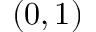Convert formula to latex. <formula><loc_0><loc_0><loc_500><loc_500>( 0 , 1 )</formula> 